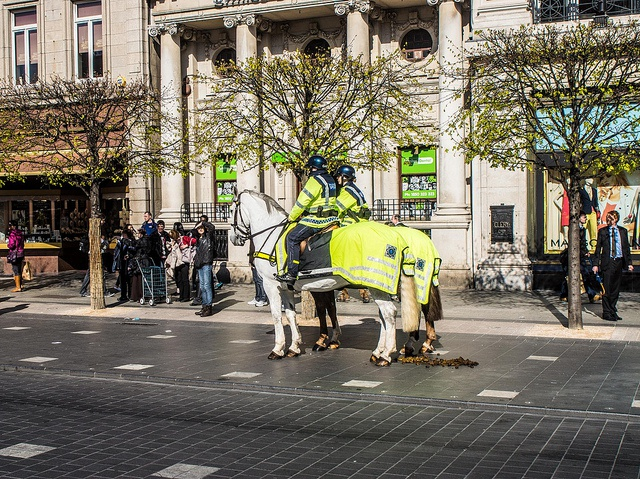Describe the objects in this image and their specific colors. I can see horse in darkgray, lightgray, khaki, yellow, and gray tones, people in darkgray, black, gray, and khaki tones, horse in darkgray, khaki, black, and beige tones, people in darkgray, black, maroon, gray, and lightgray tones, and people in darkgray, black, khaki, and darkgreen tones in this image. 